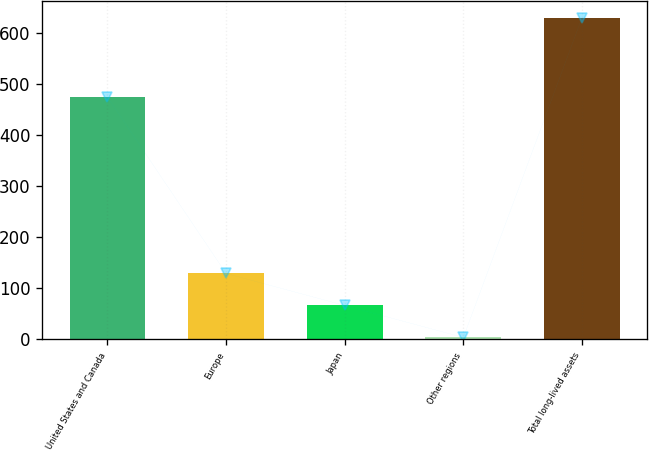Convert chart. <chart><loc_0><loc_0><loc_500><loc_500><bar_chart><fcel>United States and Canada<fcel>Europe<fcel>Japan<fcel>Other regions<fcel>Total long-lived assets<nl><fcel>474.5<fcel>129.08<fcel>66.49<fcel>3.9<fcel>629.8<nl></chart> 